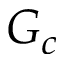<formula> <loc_0><loc_0><loc_500><loc_500>G _ { c }</formula> 